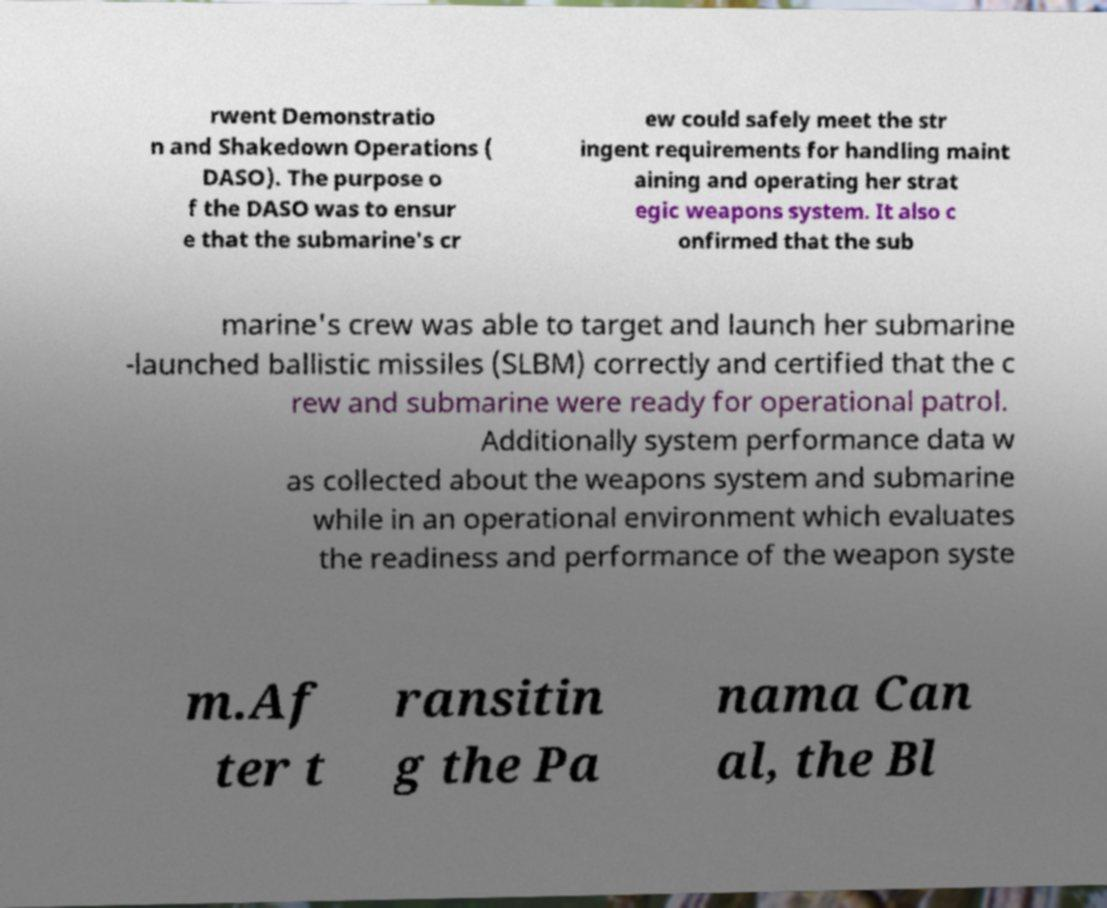Please read and relay the text visible in this image. What does it say? rwent Demonstratio n and Shakedown Operations ( DASO). The purpose o f the DASO was to ensur e that the submarine's cr ew could safely meet the str ingent requirements for handling maint aining and operating her strat egic weapons system. It also c onfirmed that the sub marine's crew was able to target and launch her submarine -launched ballistic missiles (SLBM) correctly and certified that the c rew and submarine were ready for operational patrol. Additionally system performance data w as collected about the weapons system and submarine while in an operational environment which evaluates the readiness and performance of the weapon syste m.Af ter t ransitin g the Pa nama Can al, the Bl 